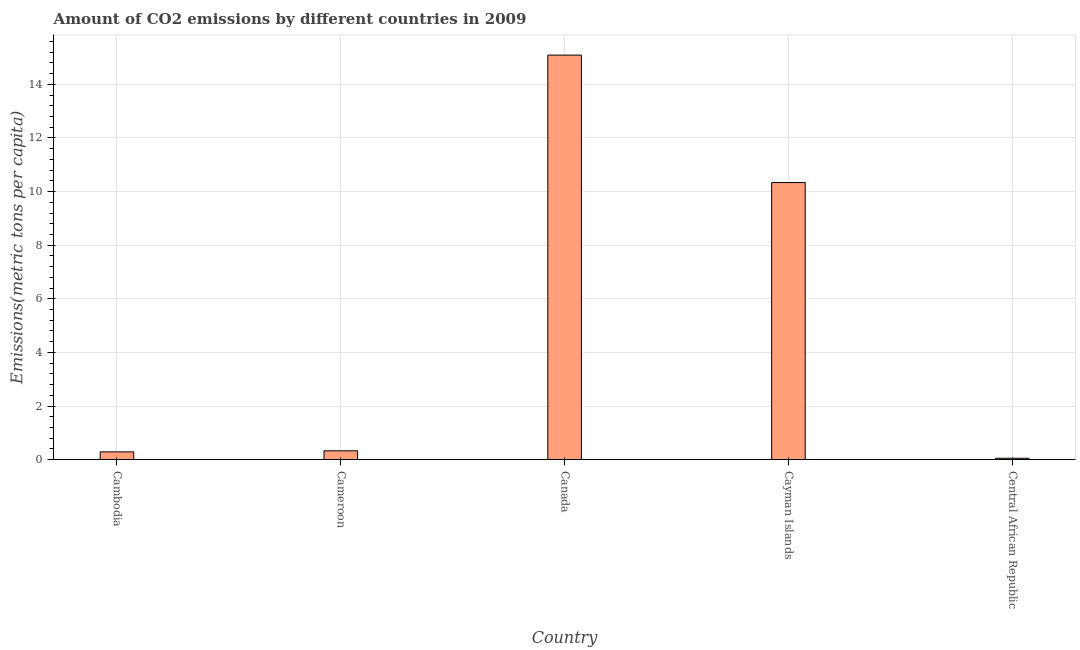What is the title of the graph?
Your answer should be very brief. Amount of CO2 emissions by different countries in 2009. What is the label or title of the X-axis?
Provide a succinct answer. Country. What is the label or title of the Y-axis?
Keep it short and to the point. Emissions(metric tons per capita). What is the amount of co2 emissions in Cambodia?
Offer a terse response. 0.29. Across all countries, what is the maximum amount of co2 emissions?
Your answer should be very brief. 15.09. Across all countries, what is the minimum amount of co2 emissions?
Offer a very short reply. 0.05. In which country was the amount of co2 emissions minimum?
Offer a terse response. Central African Republic. What is the sum of the amount of co2 emissions?
Your answer should be compact. 26.1. What is the difference between the amount of co2 emissions in Cambodia and Cameroon?
Your answer should be very brief. -0.04. What is the average amount of co2 emissions per country?
Offer a terse response. 5.22. What is the median amount of co2 emissions?
Ensure brevity in your answer.  0.33. What is the ratio of the amount of co2 emissions in Cayman Islands to that in Central African Republic?
Ensure brevity in your answer.  192.07. Is the difference between the amount of co2 emissions in Cameroon and Central African Republic greater than the difference between any two countries?
Your answer should be very brief. No. What is the difference between the highest and the second highest amount of co2 emissions?
Offer a terse response. 4.75. What is the difference between the highest and the lowest amount of co2 emissions?
Your answer should be very brief. 15.04. In how many countries, is the amount of co2 emissions greater than the average amount of co2 emissions taken over all countries?
Give a very brief answer. 2. How many countries are there in the graph?
Your answer should be very brief. 5. What is the difference between two consecutive major ticks on the Y-axis?
Provide a short and direct response. 2. What is the Emissions(metric tons per capita) of Cambodia?
Provide a succinct answer. 0.29. What is the Emissions(metric tons per capita) of Cameroon?
Your response must be concise. 0.33. What is the Emissions(metric tons per capita) in Canada?
Make the answer very short. 15.09. What is the Emissions(metric tons per capita) in Cayman Islands?
Ensure brevity in your answer.  10.34. What is the Emissions(metric tons per capita) in Central African Republic?
Your response must be concise. 0.05. What is the difference between the Emissions(metric tons per capita) in Cambodia and Cameroon?
Offer a very short reply. -0.04. What is the difference between the Emissions(metric tons per capita) in Cambodia and Canada?
Keep it short and to the point. -14.8. What is the difference between the Emissions(metric tons per capita) in Cambodia and Cayman Islands?
Ensure brevity in your answer.  -10.04. What is the difference between the Emissions(metric tons per capita) in Cambodia and Central African Republic?
Offer a terse response. 0.24. What is the difference between the Emissions(metric tons per capita) in Cameroon and Canada?
Offer a terse response. -14.76. What is the difference between the Emissions(metric tons per capita) in Cameroon and Cayman Islands?
Offer a terse response. -10. What is the difference between the Emissions(metric tons per capita) in Cameroon and Central African Republic?
Make the answer very short. 0.28. What is the difference between the Emissions(metric tons per capita) in Canada and Cayman Islands?
Provide a short and direct response. 4.75. What is the difference between the Emissions(metric tons per capita) in Canada and Central African Republic?
Offer a very short reply. 15.04. What is the difference between the Emissions(metric tons per capita) in Cayman Islands and Central African Republic?
Your response must be concise. 10.28. What is the ratio of the Emissions(metric tons per capita) in Cambodia to that in Cameroon?
Your answer should be very brief. 0.88. What is the ratio of the Emissions(metric tons per capita) in Cambodia to that in Canada?
Provide a short and direct response. 0.02. What is the ratio of the Emissions(metric tons per capita) in Cambodia to that in Cayman Islands?
Make the answer very short. 0.03. What is the ratio of the Emissions(metric tons per capita) in Cambodia to that in Central African Republic?
Offer a terse response. 5.43. What is the ratio of the Emissions(metric tons per capita) in Cameroon to that in Canada?
Make the answer very short. 0.02. What is the ratio of the Emissions(metric tons per capita) in Cameroon to that in Cayman Islands?
Your response must be concise. 0.03. What is the ratio of the Emissions(metric tons per capita) in Cameroon to that in Central African Republic?
Provide a succinct answer. 6.18. What is the ratio of the Emissions(metric tons per capita) in Canada to that in Cayman Islands?
Give a very brief answer. 1.46. What is the ratio of the Emissions(metric tons per capita) in Canada to that in Central African Republic?
Provide a short and direct response. 280.42. What is the ratio of the Emissions(metric tons per capita) in Cayman Islands to that in Central African Republic?
Your answer should be compact. 192.07. 